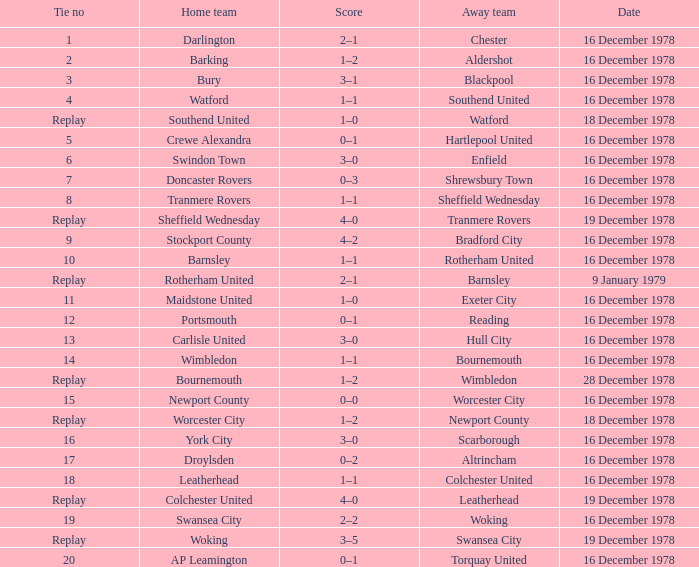What is the tie no for the away team altrincham? 17.0. 